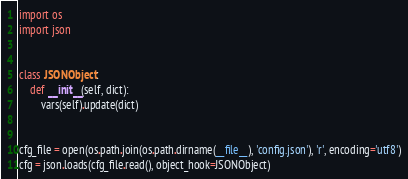<code> <loc_0><loc_0><loc_500><loc_500><_Python_>import os
import json


class JSONObject:
    def __init__(self, dict):
        vars(self).update(dict)


cfg_file = open(os.path.join(os.path.dirname(__file__), 'config.json'), 'r', encoding='utf8')
cfg = json.loads(cfg_file.read(), object_hook=JSONObject)
</code> 